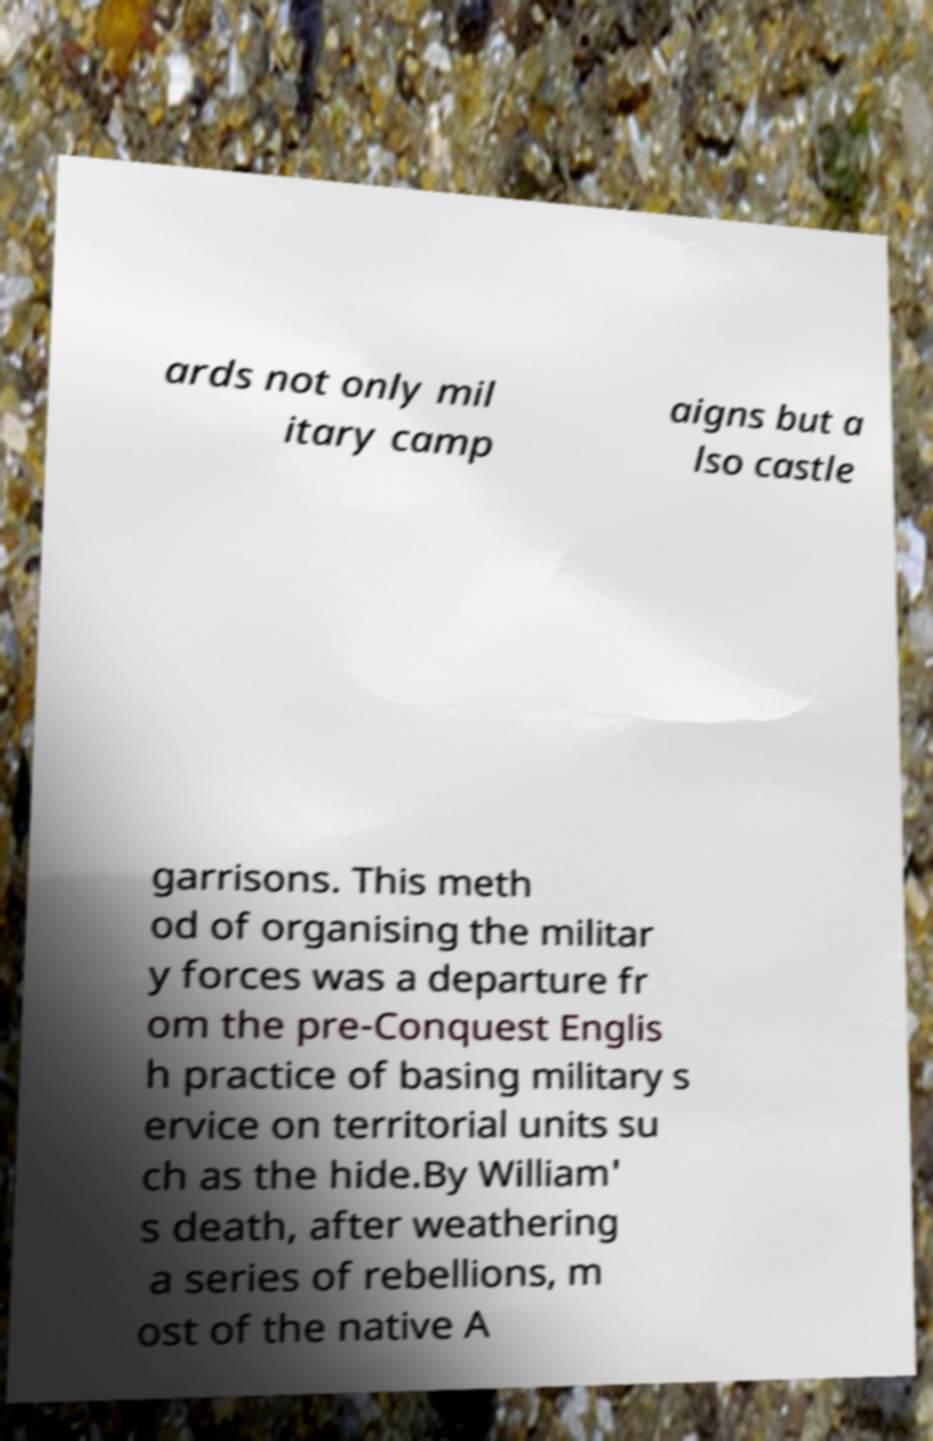Please read and relay the text visible in this image. What does it say? ards not only mil itary camp aigns but a lso castle garrisons. This meth od of organising the militar y forces was a departure fr om the pre-Conquest Englis h practice of basing military s ervice on territorial units su ch as the hide.By William' s death, after weathering a series of rebellions, m ost of the native A 